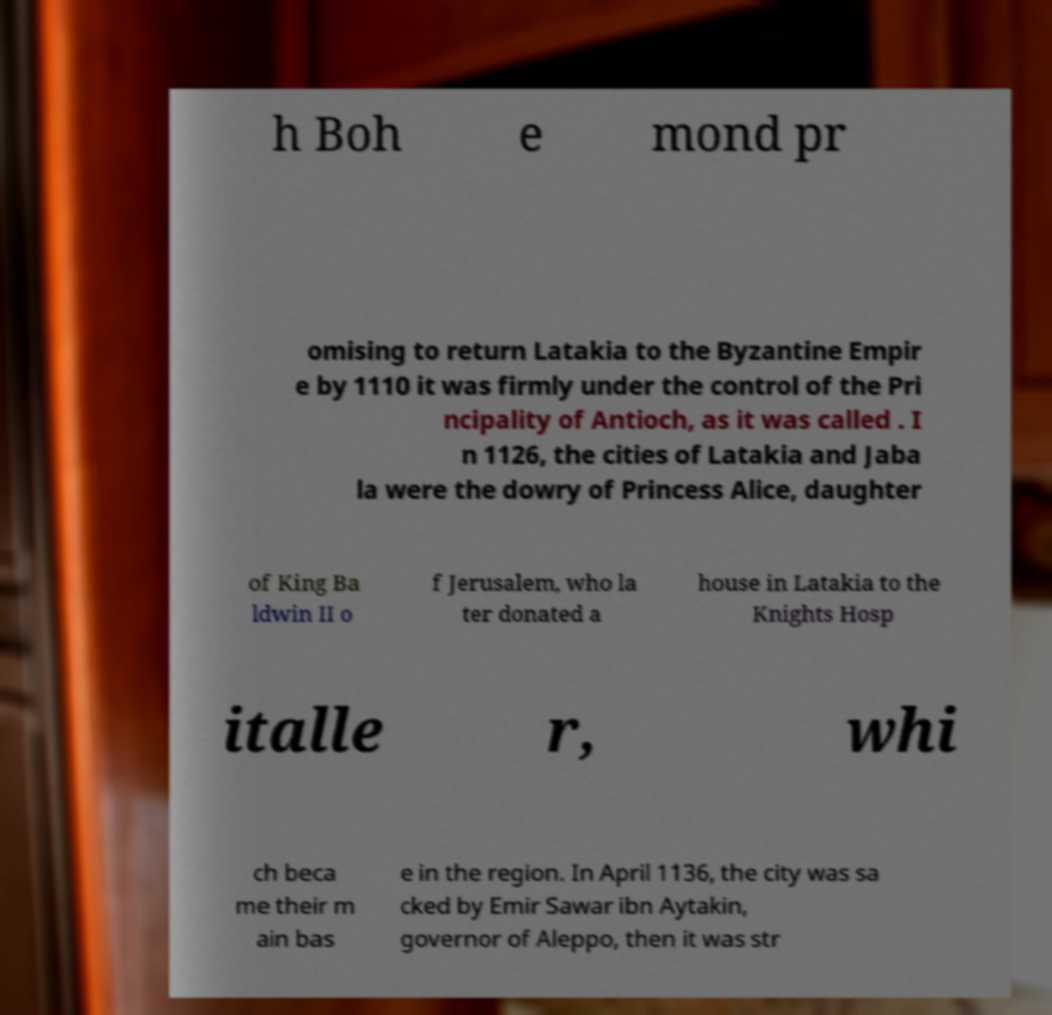There's text embedded in this image that I need extracted. Can you transcribe it verbatim? h Boh e mond pr omising to return Latakia to the Byzantine Empir e by 1110 it was firmly under the control of the Pri ncipality of Antioch, as it was called . I n 1126, the cities of Latakia and Jaba la were the dowry of Princess Alice, daughter of King Ba ldwin II o f Jerusalem, who la ter donated a house in Latakia to the Knights Hosp italle r, whi ch beca me their m ain bas e in the region. In April 1136, the city was sa cked by Emir Sawar ibn Aytakin, governor of Aleppo, then it was str 